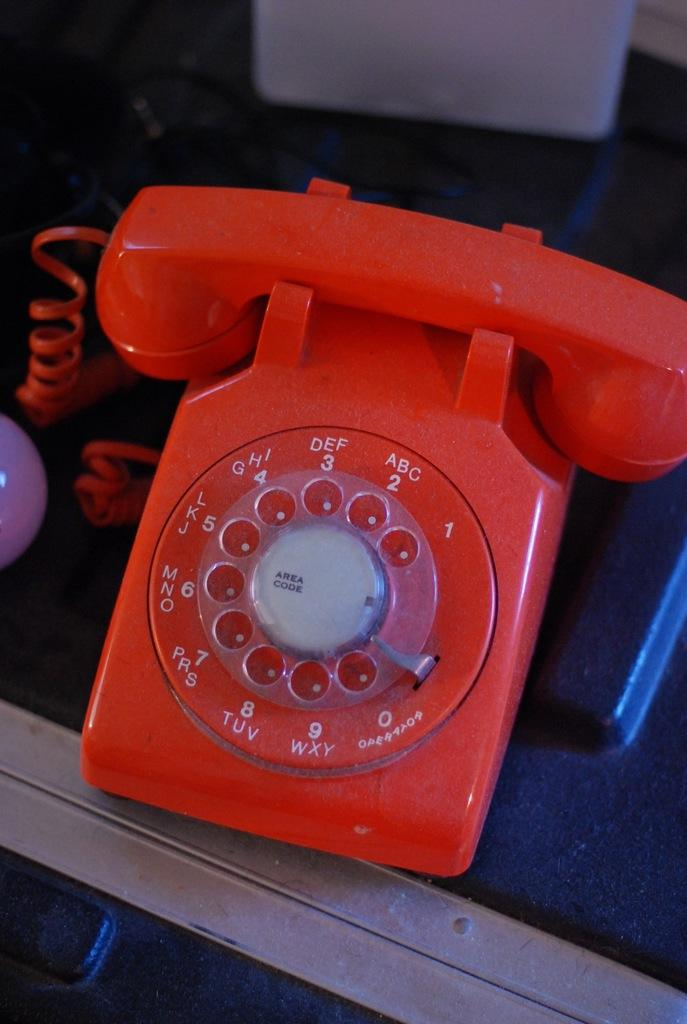<image>
Render a clear and concise summary of the photo. A red old phone that has area code written in the middle of it. 